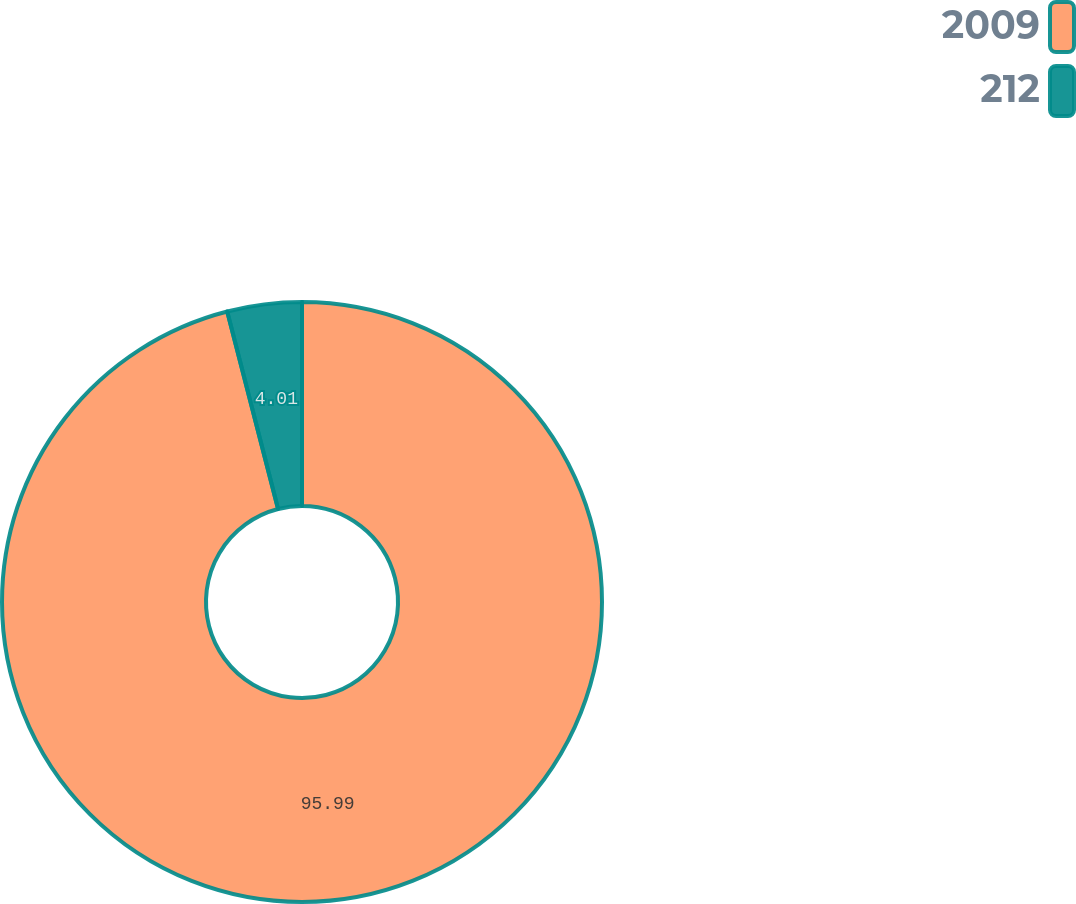Convert chart. <chart><loc_0><loc_0><loc_500><loc_500><pie_chart><fcel>2009<fcel>212<nl><fcel>95.99%<fcel>4.01%<nl></chart> 